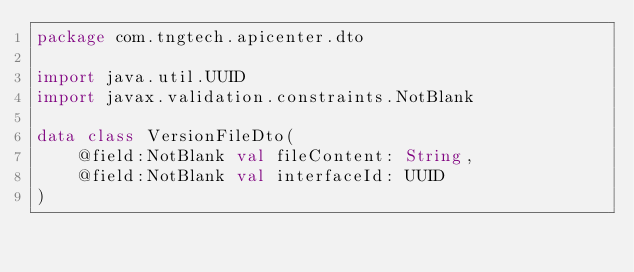<code> <loc_0><loc_0><loc_500><loc_500><_Kotlin_>package com.tngtech.apicenter.dto

import java.util.UUID
import javax.validation.constraints.NotBlank

data class VersionFileDto(
    @field:NotBlank val fileContent: String,
    @field:NotBlank val interfaceId: UUID
)
</code> 